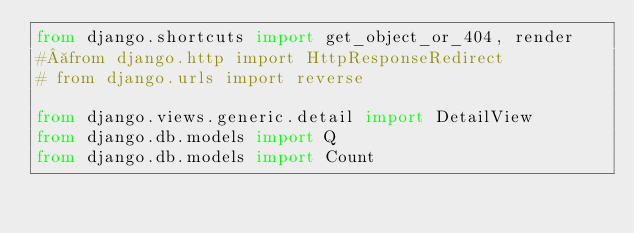Convert code to text. <code><loc_0><loc_0><loc_500><loc_500><_Python_>from django.shortcuts import get_object_or_404, render
# from django.http import HttpResponseRedirect
# from django.urls import reverse

from django.views.generic.detail import DetailView
from django.db.models import Q
from django.db.models import Count</code> 